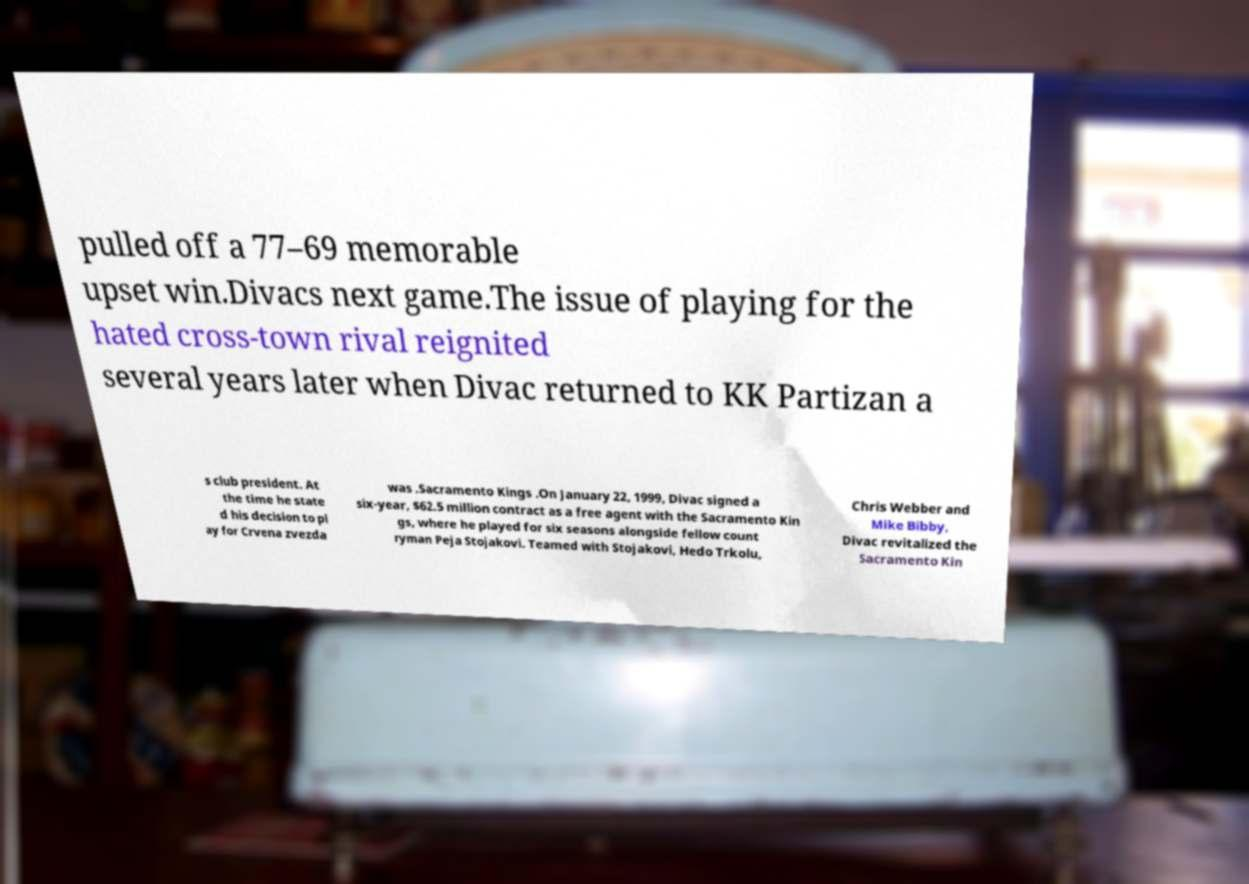Could you extract and type out the text from this image? pulled off a 77–69 memorable upset win.Divacs next game.The issue of playing for the hated cross-town rival reignited several years later when Divac returned to KK Partizan a s club president. At the time he state d his decision to pl ay for Crvena zvezda was .Sacramento Kings .On January 22, 1999, Divac signed a six-year, $62.5 million contract as a free agent with the Sacramento Kin gs, where he played for six seasons alongside fellow count ryman Peja Stojakovi. Teamed with Stojakovi, Hedo Trkolu, Chris Webber and Mike Bibby, Divac revitalized the Sacramento Kin 